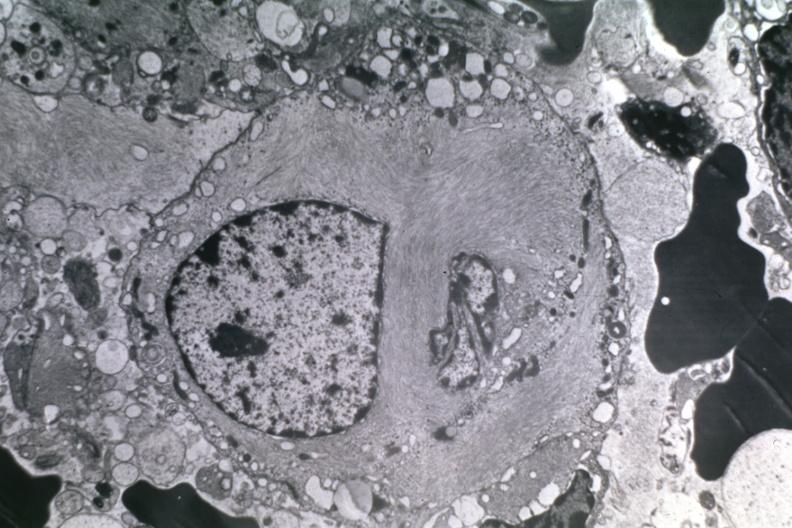s fibroma present?
Answer the question using a single word or phrase. No 